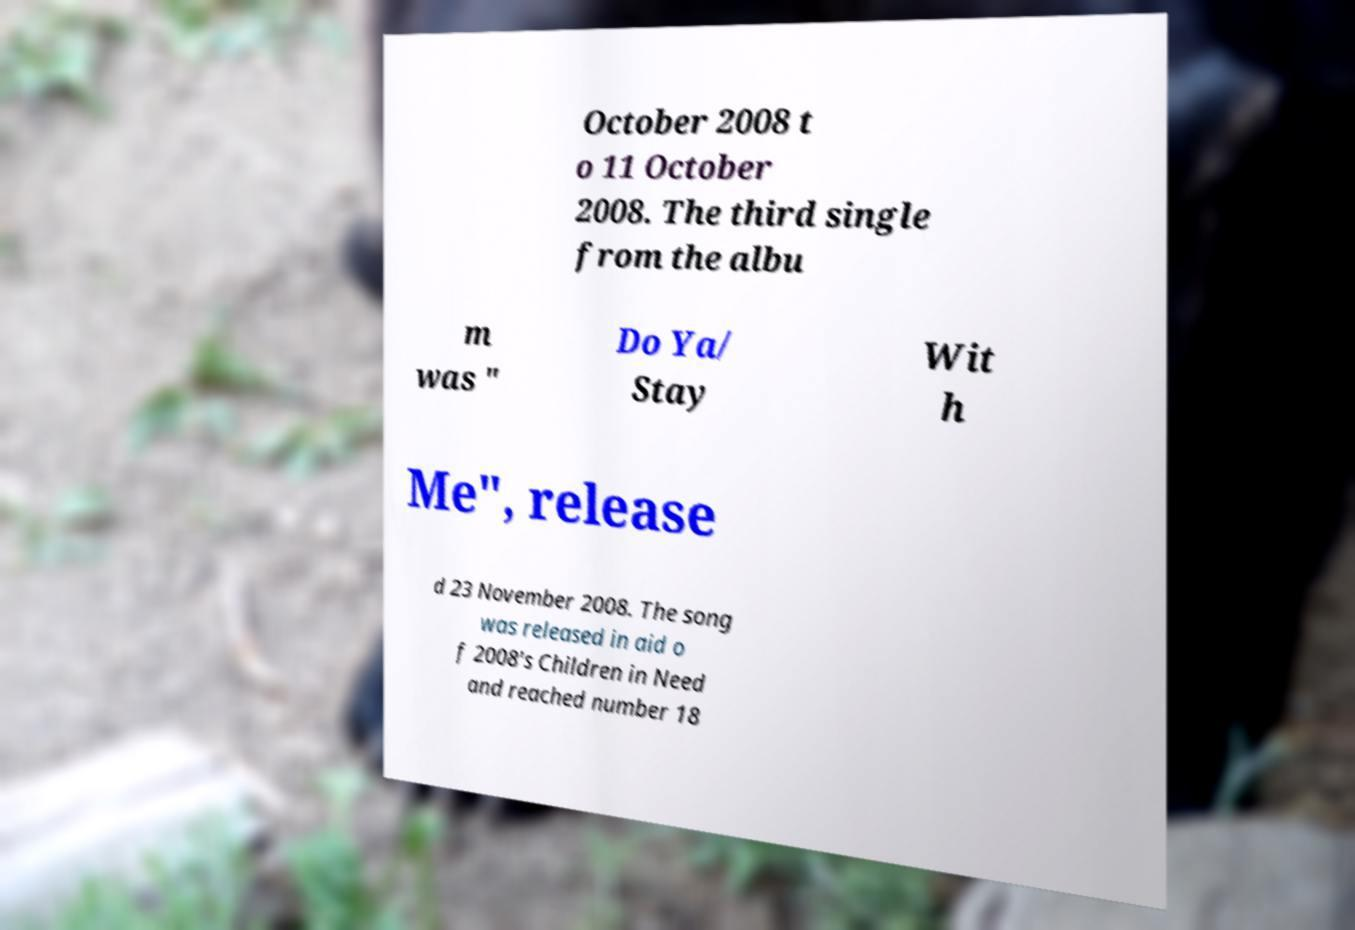What messages or text are displayed in this image? I need them in a readable, typed format. October 2008 t o 11 October 2008. The third single from the albu m was " Do Ya/ Stay Wit h Me", release d 23 November 2008. The song was released in aid o f 2008's Children in Need and reached number 18 